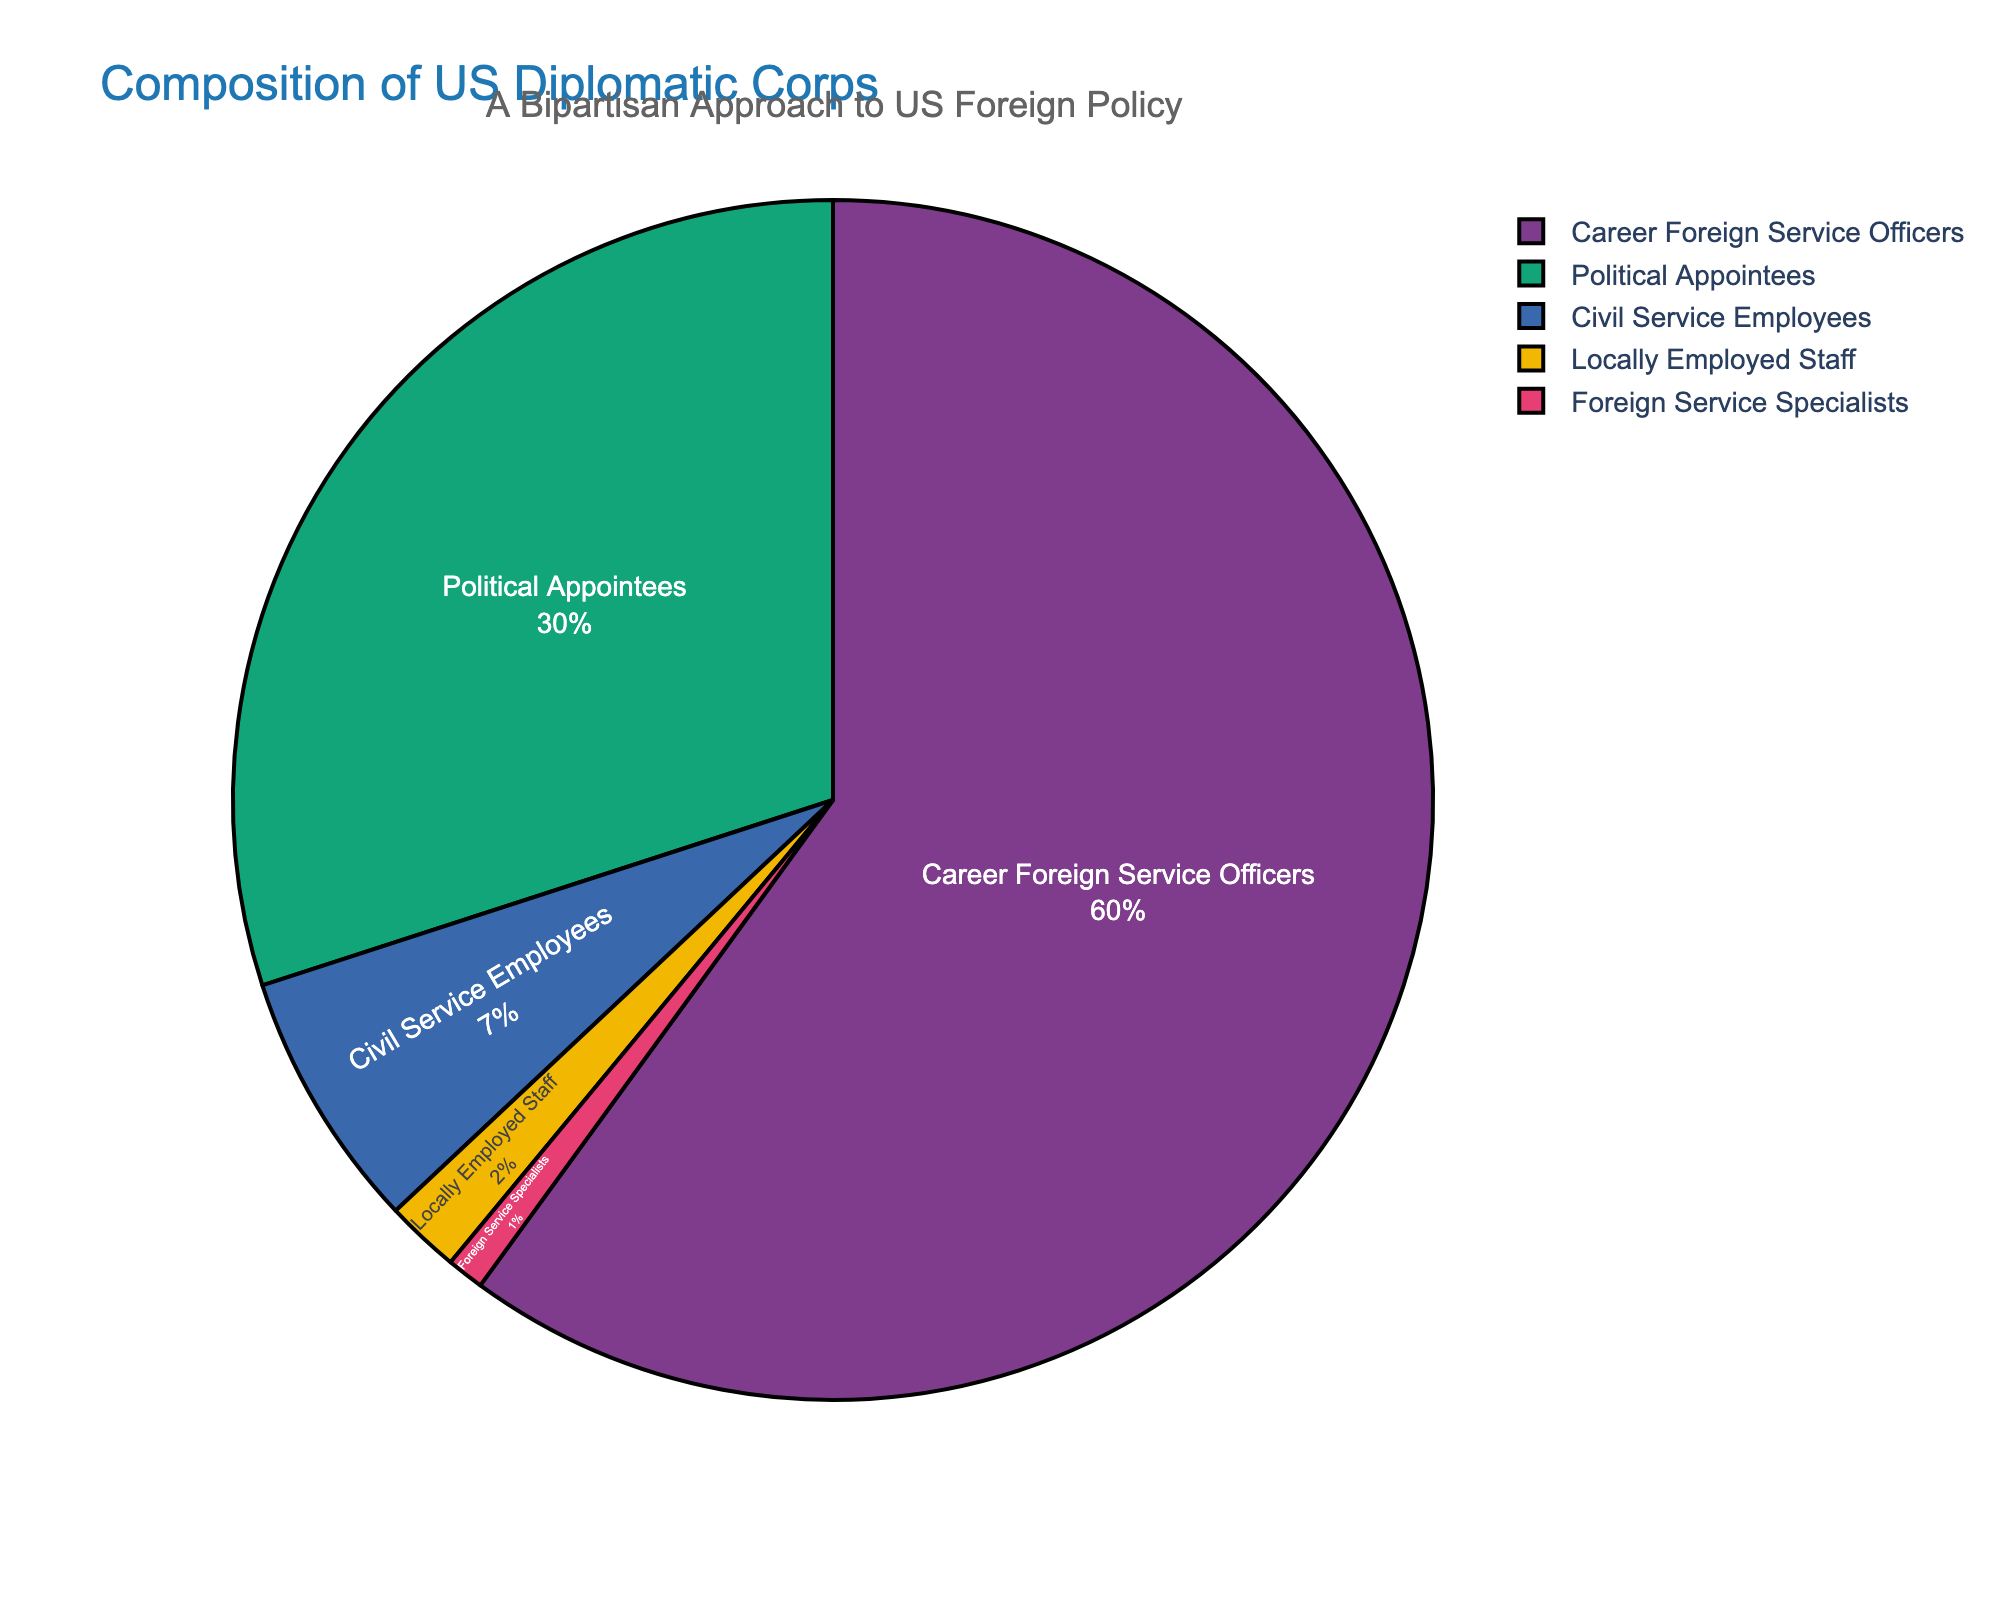What is the percentage of Career Foreign Service Officers and Political Appointees combined? To find the combined percentage of Career Foreign Service Officers and Political Appointees, simply add their respective percentages: 60% (Career Foreign Service Officers) + 30% (Political Appointees) = 90%.
Answer: 90% Which category has the smallest representation in the US Diplomatic Corps? By examining the pie chart, we see that Foreign Service Specialists have the smallest slice, representing only 1% of the US Diplomatic Corps.
Answer: Foreign Service Specialists Is the percentage of Career Foreign Service Officers greater than the combined percentage of Civil Service Employees, Locally Employed Staff, and Foreign Service Specialists? First, add the percentages of Civil Service Employees (7%), Locally Employed Staff (2%), and Foreign Service Specialists (1%): 7% + 2% + 1% = 10%. Then, compare this to the percentage of Career Foreign Service Officers, which is 60%. Since 60% > 10%, the percentage is indeed greater.
Answer: Yes What is the difference in percentage between Political Appointees and Civil Service Employees? To find the difference between the percentages of Political Appointees and Civil Service Employees, subtract the smaller percentage (7%) from the larger percentage (30%): 30% - 7% = 23%.
Answer: 23% What portion of the US Diplomatic Corps is made up of non-Career Foreign Service Officers? To find the portion of non-Career Foreign Service Officers, add the percentages of all other categories: Political Appointees (30%) + Civil Service Employees (7%) + Locally Employed Staff (2%) + Foreign Service Specialists (1%). Sum these values to get: 30% + 7% + 2% + 1% = 40%.
Answer: 40% Which category has more representation: Civil Service Employees or Locally Employed Staff and Foreign Service Specialists combined? Add the percentages for Locally Employed Staff and Foreign Service Specialists: 2% + 1% = 3%. Then compare this combined percentage with Civil Service Employees, which is 7%. Since 7% > 3%, Civil Service Employees have more representation.
Answer: Civil Service Employees By how much does the percentage of Career Foreign Service Officers exceed the percentage of Political Appointees? Subtract the percentage of Political Appointees (30%) from the percentage of Career Foreign Service Officers (60%): 60% - 30% = 30%.
Answer: 30% What is the combined percentage of Locally Employed Staff and Foreign Service Specialists? Simply add the percentages of Locally Employed Staff (2%) and Foreign Service Specialists (1%): 2% + 1% = 3%.
Answer: 3% Which categories combined form exactly 10% of the US Diplomatic Corps? Adding the percentages of Civil Service Employees (7%), Locally Employed Staff (2%), and Foreign Service Specialists (1%) gives: 7% + 2% + 1% = 10%.
Answer: Civil Service Employees, Locally Employed Staff, Foreign Service Specialists 